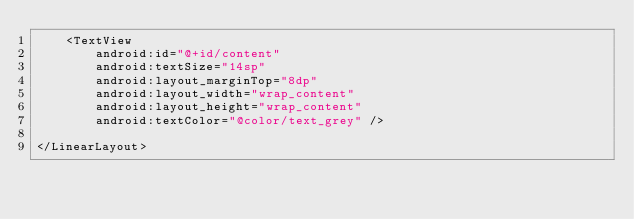<code> <loc_0><loc_0><loc_500><loc_500><_XML_>    <TextView
        android:id="@+id/content"
        android:textSize="14sp"
        android:layout_marginTop="8dp"
        android:layout_width="wrap_content"
        android:layout_height="wrap_content"
        android:textColor="@color/text_grey" />

</LinearLayout></code> 